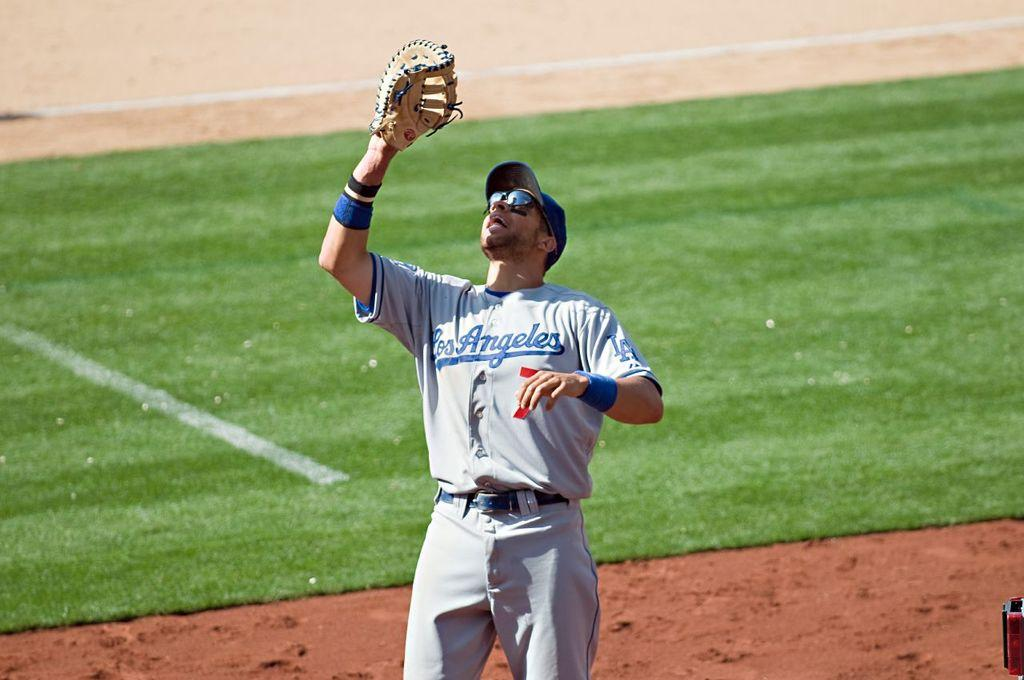What is the main subject of the image? The main subject of the image is a man. What accessories is the man wearing in the image? The man is wearing spectacles and a hat in the image. What object is the man holding in the image? The man is holding a baseball glove in the image. What position is the man in the image? The man is standing in the image. What type of environment can be seen in the background of the image? There is grass in the background of the image. What is the man's weight in the image? The image does not provide information about the man's weight, so it cannot be determined. What is the man's fear in the image? The image does not provide information about the man's fears, so it cannot be determined. 